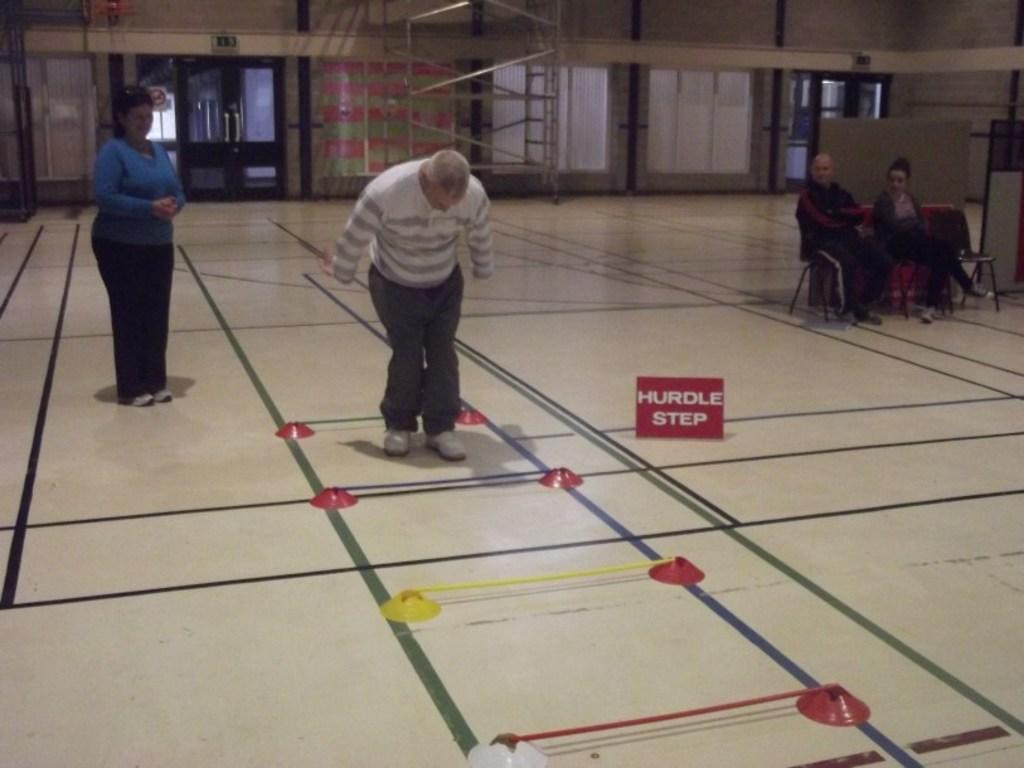Please provide a concise description of this image. This picture describes about group of people, few are standing and few are seated on the chairs, in the background we can see few metal rods, and doors. 